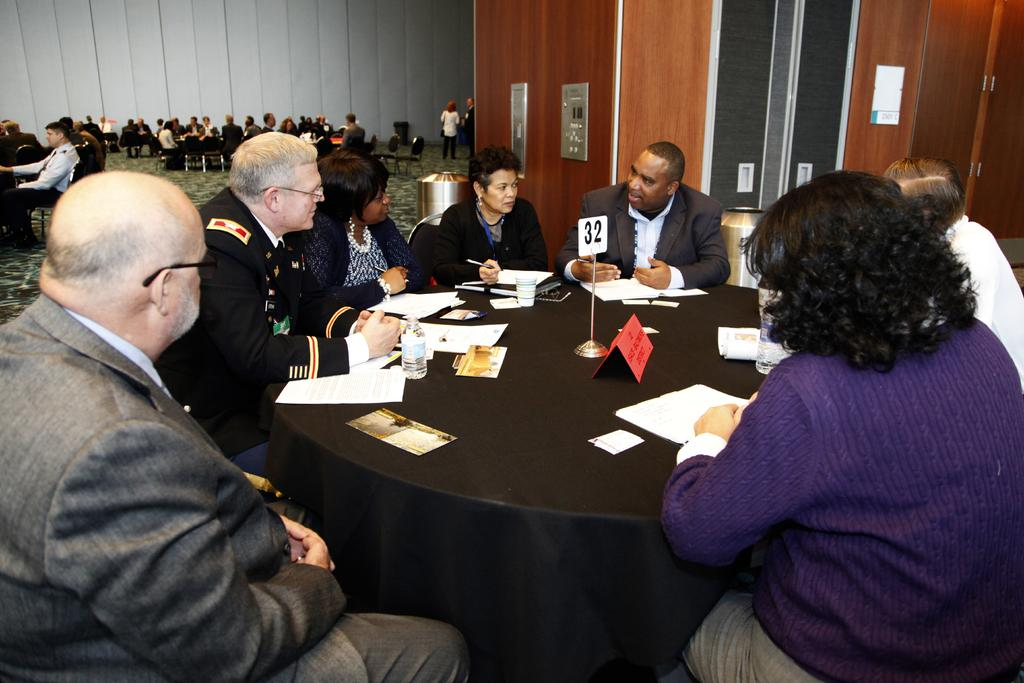What are the people in the image doing? There is a group of people seated on chairs, suggesting they might be participating in a meeting or gathering. What is on the table in the image? There are papers on a table, which could be related to the purpose of the gathering. Are there any other groups of people in the image? Yes, there are additional groups of people seated on chairs, indicating that there might be multiple discussions or activities taking place. What is the position of some people in the image? A couple of people are standing, which could indicate that they are either joining the seated groups or waiting for their turn to participate. What type of ice can be seen melting on the throat of one of the standing people in the image? There is no ice visible in the image, and no one's throat is mentioned or depicted. 